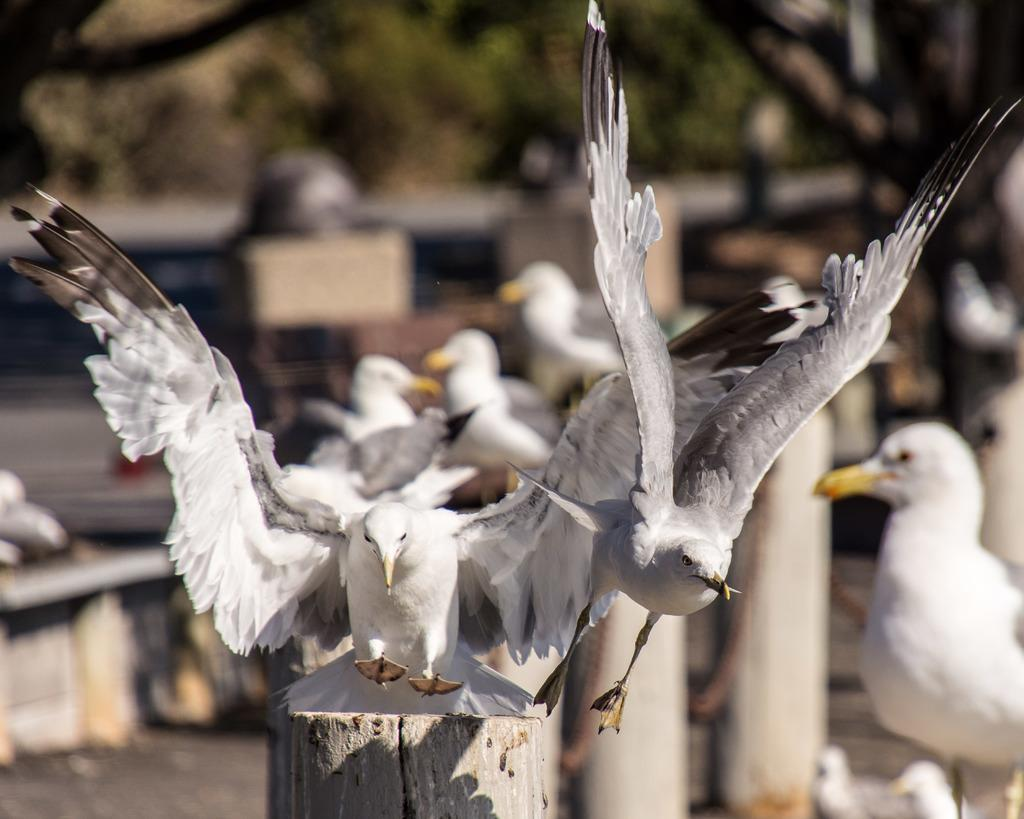What type of view is shown in the image? The image is an outside view. What structures can be seen at the bottom of the image? There are wooden poles at the bottom of the image. What type of animals are visible in the image? There are many birds visible in the image. What type of vegetation is visible at the top of the image? Leaves are visible at the top of the image. How would you describe the background of the image? The background of the image is blurred. Can you see the ocean in the background of the image? No, the ocean is not present in the image. Is there any milk visible in the image? No, there is no milk visible in the image. 